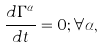<formula> <loc_0><loc_0><loc_500><loc_500>\frac { d \Gamma ^ { \alpha } } { d t } = 0 ; \forall \alpha ,</formula> 